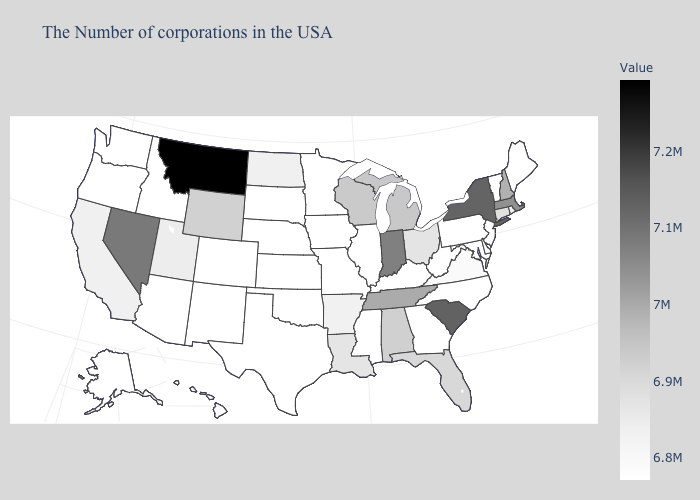Which states hav the highest value in the Northeast?
Be succinct. New York. Among the states that border California , which have the highest value?
Keep it brief. Nevada. Among the states that border Utah , which have the highest value?
Give a very brief answer. Nevada. Among the states that border Pennsylvania , which have the highest value?
Give a very brief answer. New York. 